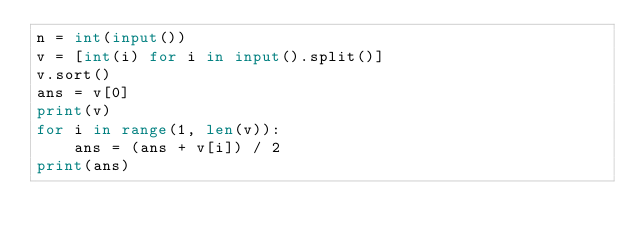Convert code to text. <code><loc_0><loc_0><loc_500><loc_500><_Python_>n = int(input())
v = [int(i) for i in input().split()]
v.sort()
ans = v[0]
print(v)
for i in range(1, len(v)):
    ans = (ans + v[i]) / 2
print(ans)
</code> 